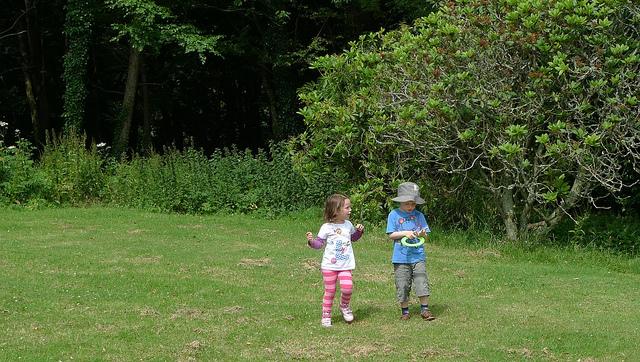Are they wearing costumes?
Answer briefly. No. Is this a public park?
Concise answer only. Yes. Are the children both older than 15?
Quick response, please. No. What is the baby holding?
Short answer required. Frisbee. How many children are playing?
Answer briefly. 2. Does the lawn need to be cut?
Keep it brief. No. What color shirt is the boy in the back wearing?
Short answer required. Blue. Why the head protection?
Write a very short answer. Sun. How many pairs of shoes are in the image?
Concise answer only. 2. Is the child running after the ball?
Short answer required. No. Where are the children sitting?
Be succinct. They are standing. What color are the girl's pants?
Short answer required. Pink. What Color is the little boy's shorts?
Be succinct. Gray. Is the child with his father?
Concise answer only. No. Is the little girl flying the kite?
Concise answer only. No. What are the children doing?
Give a very brief answer. Walking. What type of fruit grows on the trees in the background?
Short answer required. None. Which child is wearing a hat?
Quick response, please. Boy. 